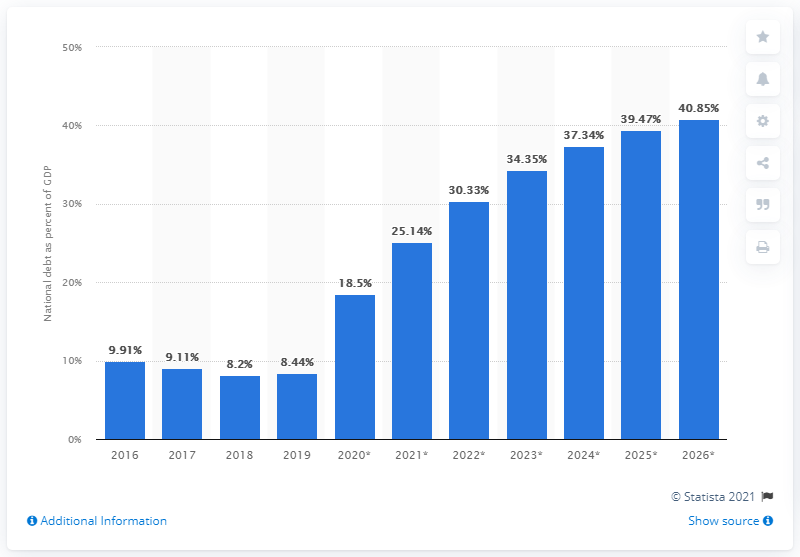What percentage of Estonia's GDP did the national debt amount to in 2019?
 8.44 